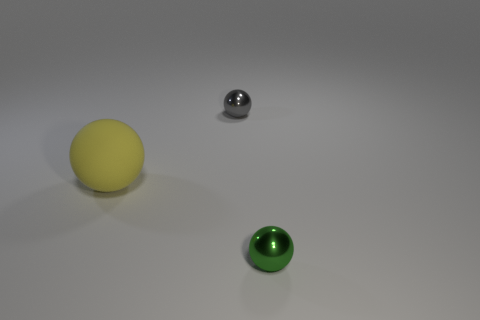There is a small thing that is to the right of the small metallic thing that is behind the matte ball that is to the left of the tiny gray thing; what is its color?
Ensure brevity in your answer.  Green. Is the material of the small ball that is behind the small green metallic thing the same as the big sphere?
Provide a short and direct response. No. Is there a sphere of the same color as the large object?
Offer a very short reply. No. Are there any rubber spheres?
Give a very brief answer. Yes. Does the ball that is to the left of the gray metallic sphere have the same size as the green metal thing?
Offer a terse response. No. Are there fewer yellow things than big green metal blocks?
Give a very brief answer. No. There is a tiny metallic object that is in front of the tiny thing that is behind the metal object on the right side of the gray metallic object; what is its shape?
Your answer should be compact. Sphere. Are there any other small things made of the same material as the gray object?
Provide a succinct answer. Yes. Does the metallic sphere behind the rubber thing have the same color as the shiny object that is in front of the gray metal sphere?
Give a very brief answer. No. Are there fewer small green things that are on the left side of the green thing than big red objects?
Make the answer very short. No. 